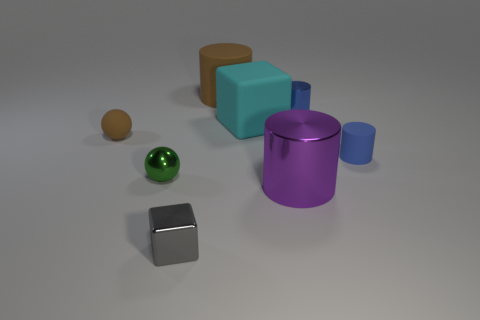Add 2 small gray shiny blocks. How many objects exist? 10 Subtract all spheres. How many objects are left? 6 Add 2 small brown spheres. How many small brown spheres are left? 3 Add 5 rubber cylinders. How many rubber cylinders exist? 7 Subtract 0 cyan balls. How many objects are left? 8 Subtract all green objects. Subtract all small cylinders. How many objects are left? 5 